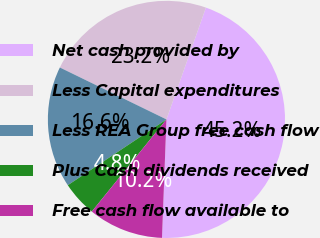Convert chart. <chart><loc_0><loc_0><loc_500><loc_500><pie_chart><fcel>Net cash provided by<fcel>Less Capital expenditures<fcel>Less REA Group free cash flow<fcel>Plus Cash dividends received<fcel>Free cash flow available to<nl><fcel>45.2%<fcel>23.19%<fcel>16.58%<fcel>4.8%<fcel>10.24%<nl></chart> 